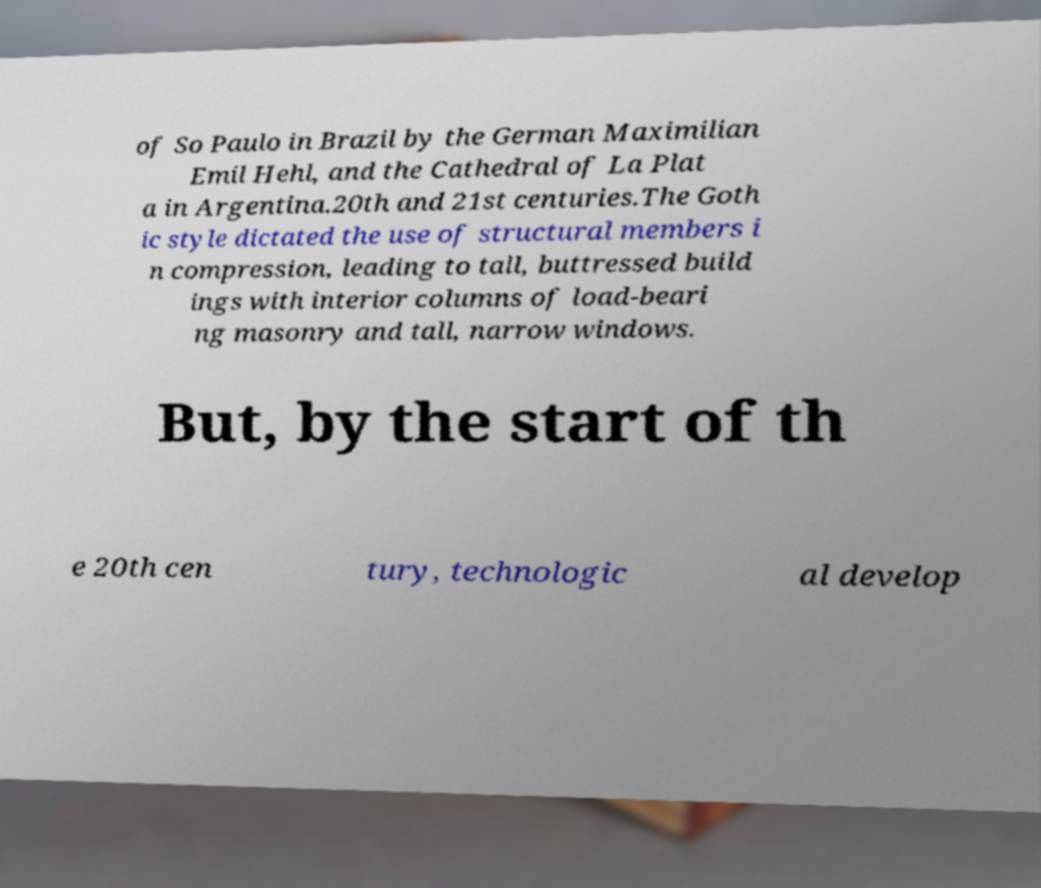Could you extract and type out the text from this image? of So Paulo in Brazil by the German Maximilian Emil Hehl, and the Cathedral of La Plat a in Argentina.20th and 21st centuries.The Goth ic style dictated the use of structural members i n compression, leading to tall, buttressed build ings with interior columns of load-beari ng masonry and tall, narrow windows. But, by the start of th e 20th cen tury, technologic al develop 